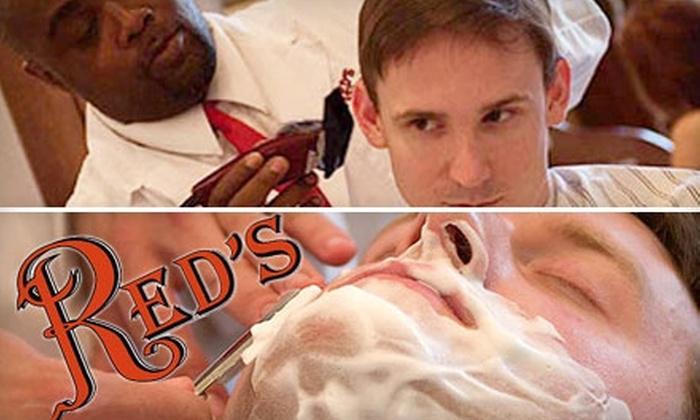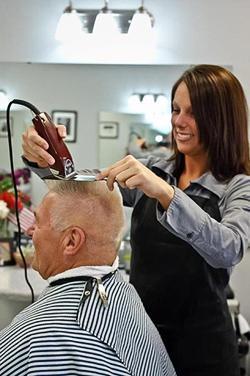The first image is the image on the left, the second image is the image on the right. Evaluate the accuracy of this statement regarding the images: "One image shows hair stylists posing with folded arms, without customers.". Is it true? Answer yes or no. No. The first image is the image on the left, the second image is the image on the right. For the images shown, is this caption "Barber stylists stand with their arms crossed in one image, while a patron receives a barbershop service in the other image." true? Answer yes or no. No. 